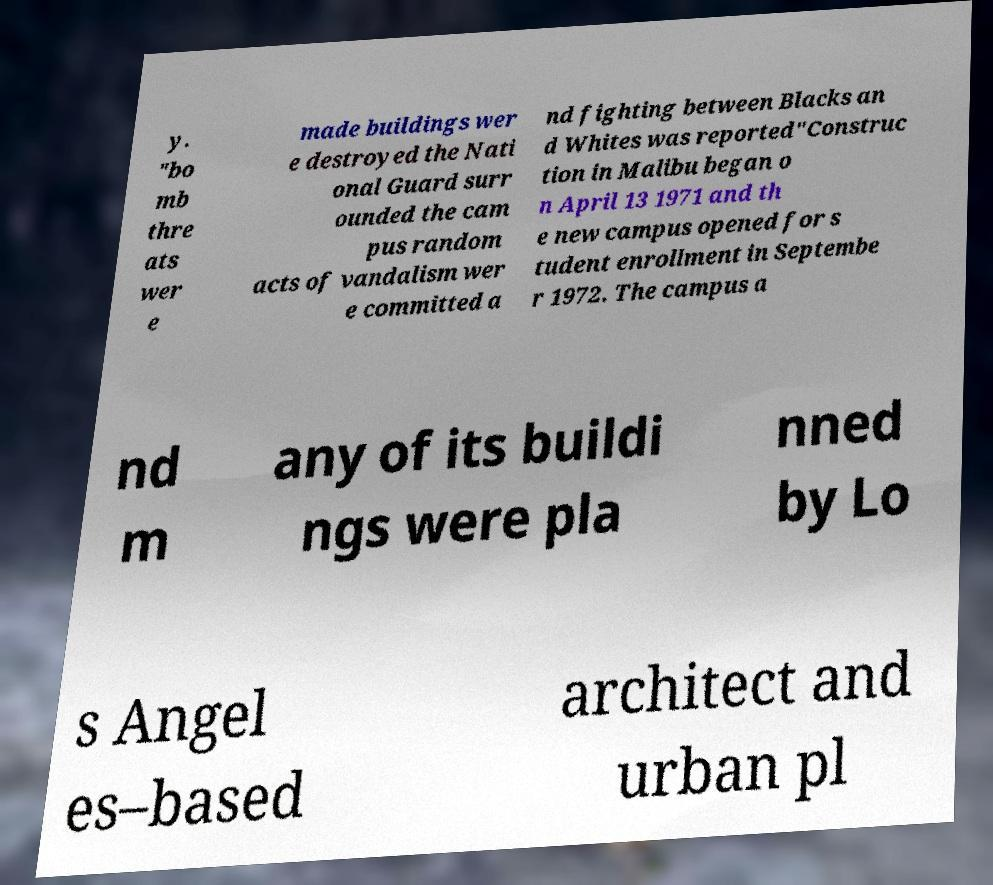There's text embedded in this image that I need extracted. Can you transcribe it verbatim? y. "bo mb thre ats wer e made buildings wer e destroyed the Nati onal Guard surr ounded the cam pus random acts of vandalism wer e committed a nd fighting between Blacks an d Whites was reported"Construc tion in Malibu began o n April 13 1971 and th e new campus opened for s tudent enrollment in Septembe r 1972. The campus a nd m any of its buildi ngs were pla nned by Lo s Angel es–based architect and urban pl 